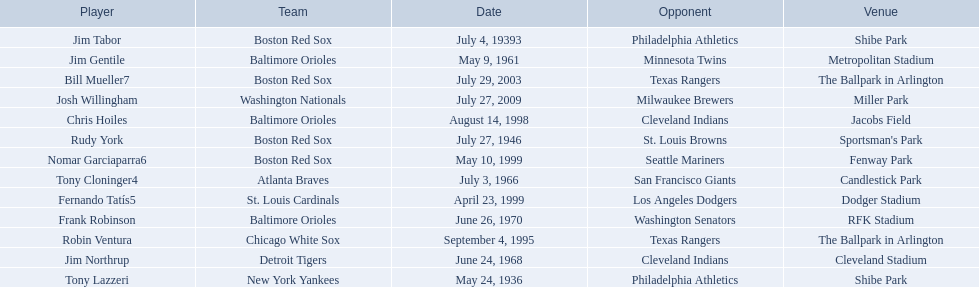Who are the opponents of the boston red sox during baseball home run records? Philadelphia Athletics, St. Louis Browns, Seattle Mariners, Texas Rangers. Of those which was the opponent on july 27, 1946? St. Louis Browns. 